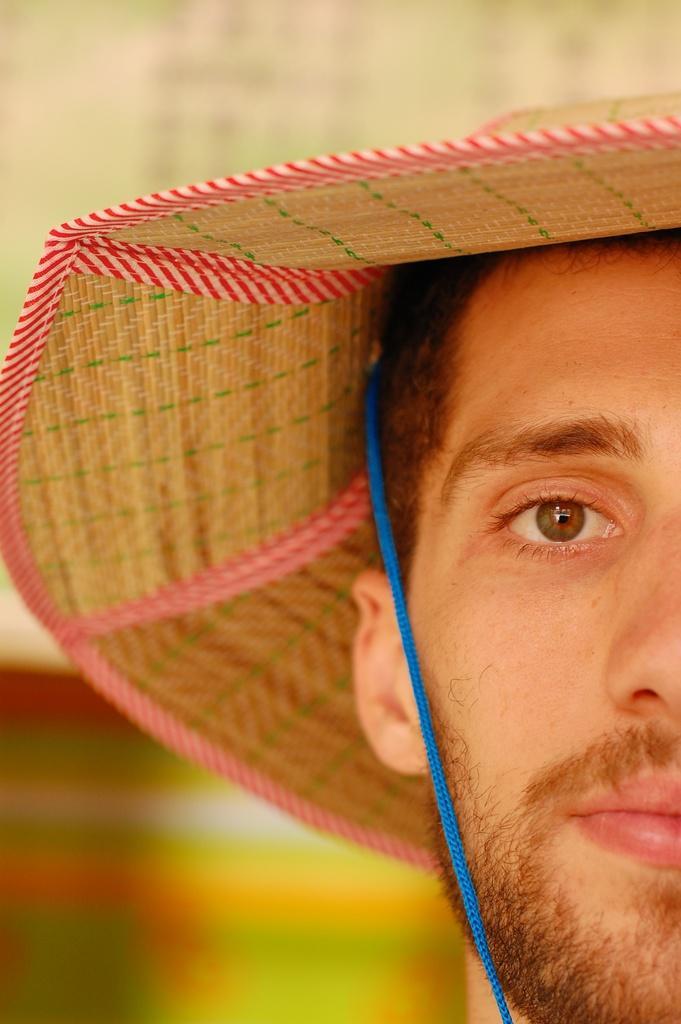In one or two sentences, can you explain what this image depicts? In this image we can see a person wearing a hat with a blue string attached to it. 